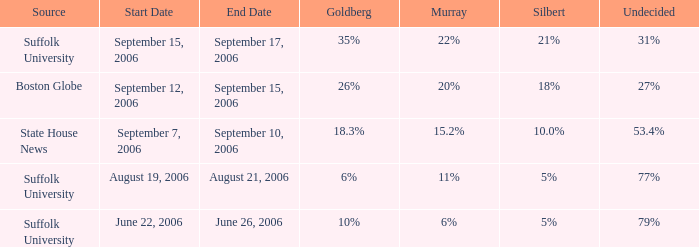What is the undetermined percentage of the suffolk university poll with murray at 11%? 77%. 